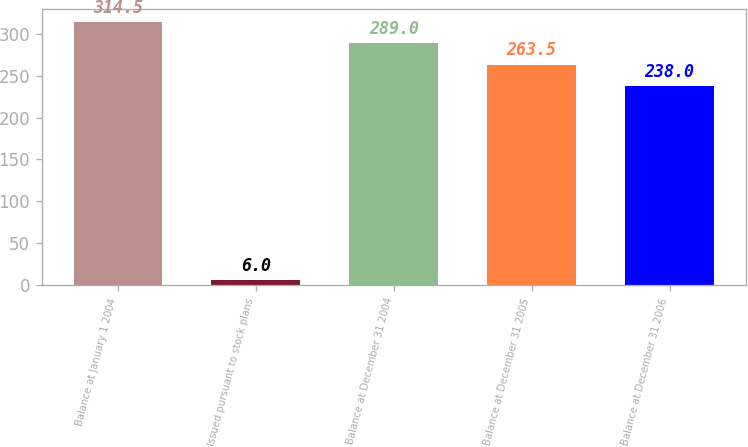Convert chart. <chart><loc_0><loc_0><loc_500><loc_500><bar_chart><fcel>Balance at January 1 2004<fcel>Issued pursuant to stock plans<fcel>Balance at December 31 2004<fcel>Balance at December 31 2005<fcel>Balance at December 31 2006<nl><fcel>314.5<fcel>6<fcel>289<fcel>263.5<fcel>238<nl></chart> 